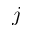Convert formula to latex. <formula><loc_0><loc_0><loc_500><loc_500>j</formula> 